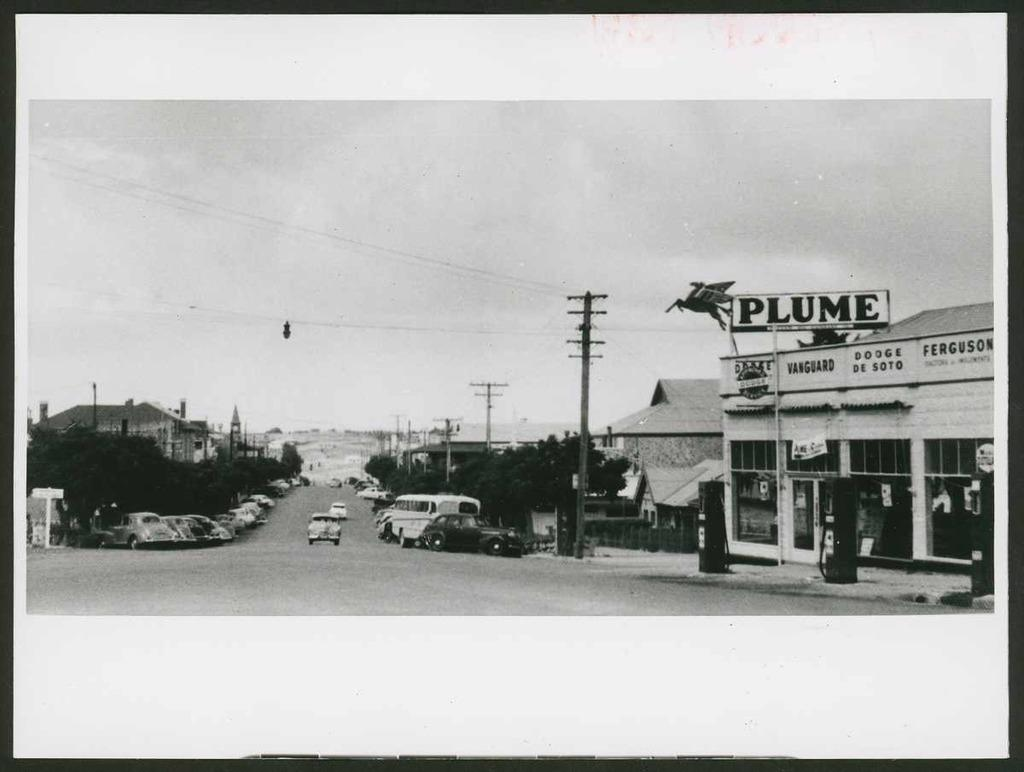<image>
Describe the image concisely. A black and white photo with a sign that says Plume on the right. 